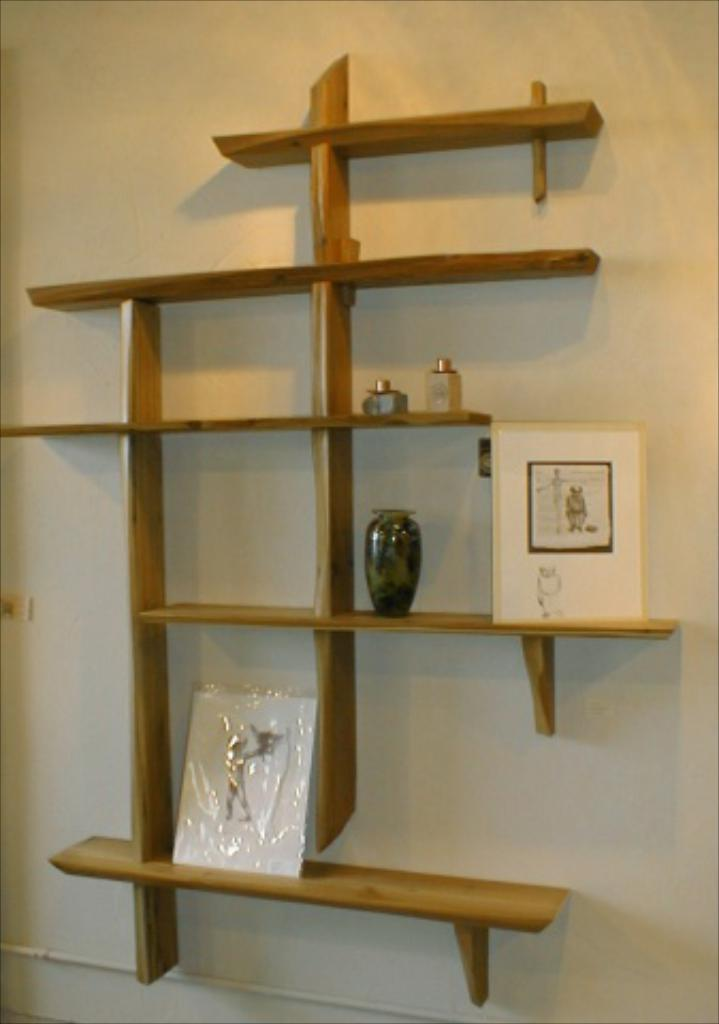What is the arrangement of objects and frames in the image? The objects and frames are arranged in a rack. Where is the rack located in the image? The rack is hanging on a wall. Can you describe the position of the rack in relation to the wall? The rack is attached to the wall and appears to be hanging from it. How many chickens are sitting on the pies in the image? There are no chickens or pies present in the image; it features a rack with objects and frames hanging on a wall. 